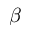<formula> <loc_0><loc_0><loc_500><loc_500>\beta</formula> 